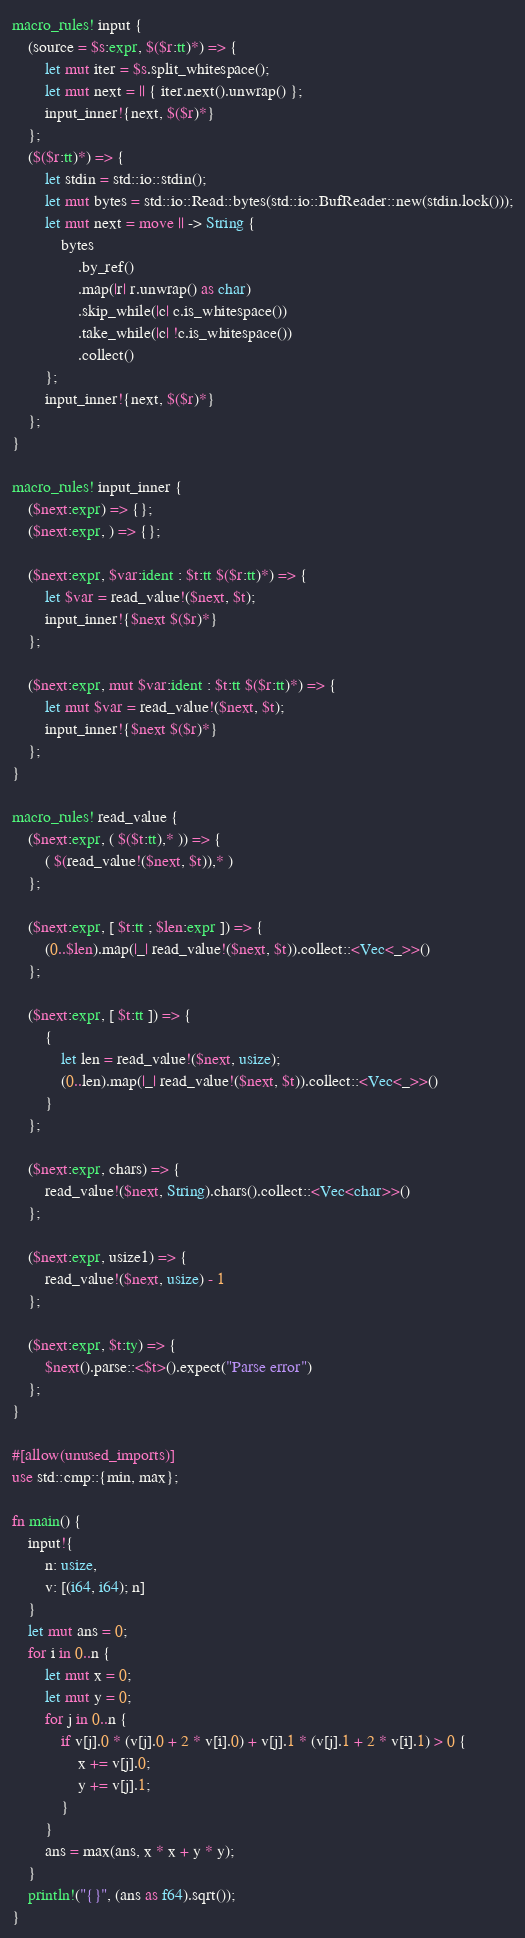Convert code to text. <code><loc_0><loc_0><loc_500><loc_500><_Rust_>macro_rules! input {
    (source = $s:expr, $($r:tt)*) => {
        let mut iter = $s.split_whitespace();
        let mut next = || { iter.next().unwrap() };
        input_inner!{next, $($r)*}
    };
    ($($r:tt)*) => {
        let stdin = std::io::stdin();
        let mut bytes = std::io::Read::bytes(std::io::BufReader::new(stdin.lock()));
        let mut next = move || -> String {
            bytes
                .by_ref()
                .map(|r| r.unwrap() as char)
                .skip_while(|c| c.is_whitespace())
                .take_while(|c| !c.is_whitespace())
                .collect()
        };
        input_inner!{next, $($r)*}
    };
}

macro_rules! input_inner {
    ($next:expr) => {};
    ($next:expr, ) => {};

    ($next:expr, $var:ident : $t:tt $($r:tt)*) => {
        let $var = read_value!($next, $t);
        input_inner!{$next $($r)*}
    };

    ($next:expr, mut $var:ident : $t:tt $($r:tt)*) => {
        let mut $var = read_value!($next, $t);
        input_inner!{$next $($r)*}
    };
}

macro_rules! read_value {
    ($next:expr, ( $($t:tt),* )) => {
        ( $(read_value!($next, $t)),* )
    };

    ($next:expr, [ $t:tt ; $len:expr ]) => {
        (0..$len).map(|_| read_value!($next, $t)).collect::<Vec<_>>()
    };

    ($next:expr, [ $t:tt ]) => {
        {
            let len = read_value!($next, usize);
            (0..len).map(|_| read_value!($next, $t)).collect::<Vec<_>>()
        }
    };

    ($next:expr, chars) => {
        read_value!($next, String).chars().collect::<Vec<char>>()
    };

    ($next:expr, usize1) => {
        read_value!($next, usize) - 1
    };

    ($next:expr, $t:ty) => {
        $next().parse::<$t>().expect("Parse error")
    };
}

#[allow(unused_imports)]
use std::cmp::{min, max};

fn main() {
    input!{
        n: usize,
        v: [(i64, i64); n]
    }
    let mut ans = 0;
    for i in 0..n {
        let mut x = 0;
        let mut y = 0;
        for j in 0..n {
            if v[j].0 * (v[j].0 + 2 * v[i].0) + v[j].1 * (v[j].1 + 2 * v[i].1) > 0 {
                x += v[j].0;
                y += v[j].1;
            }
        }
        ans = max(ans, x * x + y * y);
    }
    println!("{}", (ans as f64).sqrt());
}
</code> 